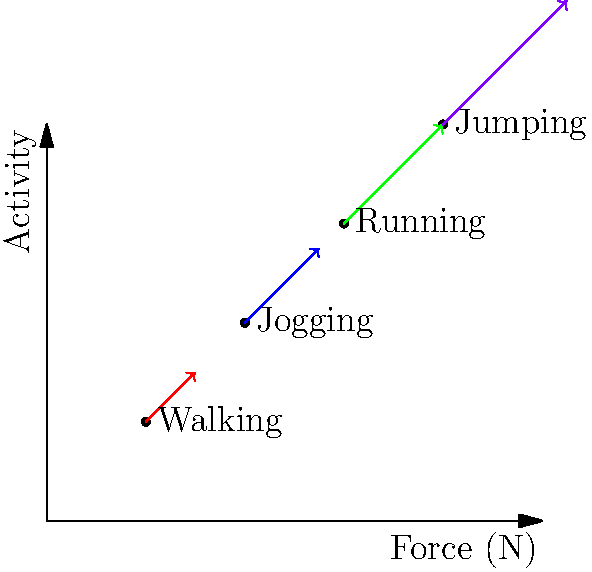Based on the force vector diagram showing the impact on knee joints during different physical activities, which activity appears to exert the highest force on the joints, and how might this information be relevant in addressing health disparities related to joint health in different populations? To answer this question, let's analyze the diagram step-by-step:

1. The diagram shows force vectors for four different activities: walking, jogging, running, and jumping.

2. The length and direction of each vector represent the magnitude and direction of force exerted on the knee joints during each activity.

3. Comparing the vectors:
   - Walking: shortest vector
   - Jogging: longer than walking
   - Running: longer than jogging
   - Jumping: longest vector

4. The jumping vector extends beyond the graph's boundaries, indicating it exerts the highest force on the knee joints.

5. Relevance to health disparities and joint health:
   a) Different populations may engage in various levels of physical activity due to socioeconomic factors, access to recreational facilities, or occupational requirements.
   b) Communities with limited access to proper footwear or exercise facilities may be at higher risk for joint issues due to improper impact absorption.
   c) Occupations requiring frequent jumping or high-impact activities may lead to increased joint wear in certain populations.
   d) Understanding these forces can help in developing targeted interventions, such as:
      - Recommending appropriate exercises based on individual joint health
      - Designing workplace interventions to reduce joint stress in high-risk occupations
      - Advocating for access to proper equipment and facilities in underserved communities
   e) This information can guide public health policies aimed at reducing joint-related health disparities across different socioeconomic groups.
Answer: Jumping exerts the highest force; relevant for addressing joint health disparities through targeted interventions and policies. 